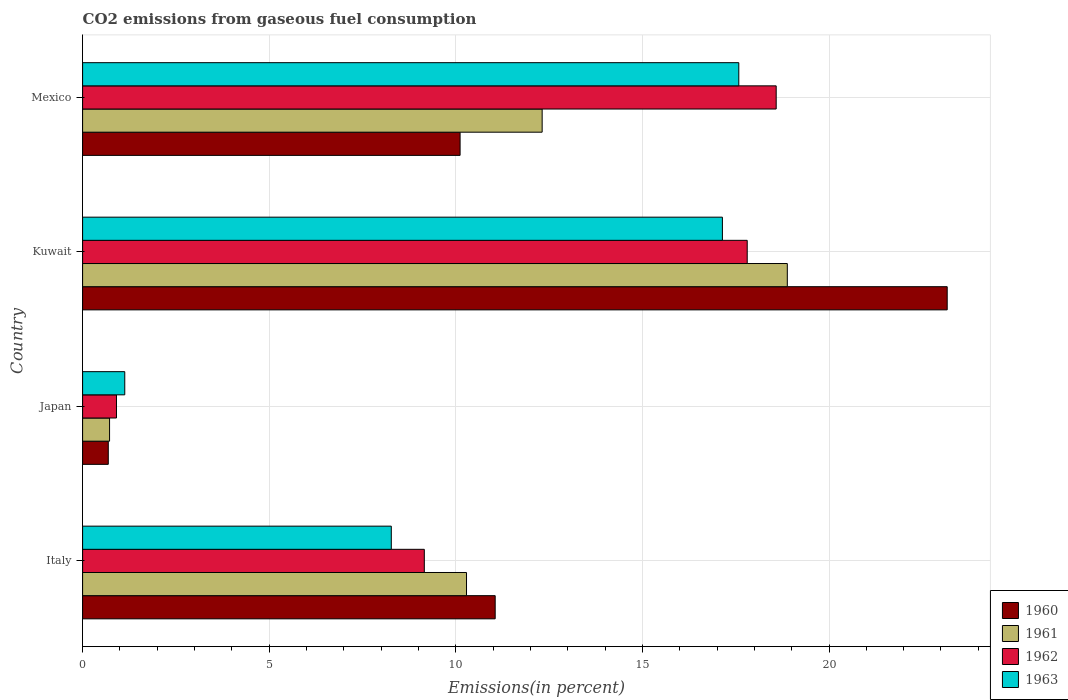How many different coloured bars are there?
Ensure brevity in your answer.  4. Are the number of bars per tick equal to the number of legend labels?
Offer a terse response. Yes. Are the number of bars on each tick of the Y-axis equal?
Make the answer very short. Yes. How many bars are there on the 3rd tick from the top?
Ensure brevity in your answer.  4. How many bars are there on the 4th tick from the bottom?
Make the answer very short. 4. What is the label of the 2nd group of bars from the top?
Your answer should be very brief. Kuwait. What is the total CO2 emitted in 1962 in Kuwait?
Offer a terse response. 17.81. Across all countries, what is the maximum total CO2 emitted in 1962?
Offer a very short reply. 18.59. Across all countries, what is the minimum total CO2 emitted in 1961?
Your answer should be compact. 0.72. What is the total total CO2 emitted in 1962 in the graph?
Give a very brief answer. 46.46. What is the difference between the total CO2 emitted in 1963 in Japan and that in Mexico?
Offer a very short reply. -16.45. What is the difference between the total CO2 emitted in 1962 in Japan and the total CO2 emitted in 1963 in Mexico?
Offer a very short reply. -16.68. What is the average total CO2 emitted in 1960 per country?
Offer a terse response. 11.26. What is the difference between the total CO2 emitted in 1961 and total CO2 emitted in 1962 in Italy?
Keep it short and to the point. 1.13. What is the ratio of the total CO2 emitted in 1963 in Japan to that in Kuwait?
Offer a terse response. 0.07. What is the difference between the highest and the second highest total CO2 emitted in 1961?
Provide a short and direct response. 6.57. What is the difference between the highest and the lowest total CO2 emitted in 1960?
Offer a very short reply. 22.48. Is the sum of the total CO2 emitted in 1962 in Italy and Kuwait greater than the maximum total CO2 emitted in 1960 across all countries?
Make the answer very short. Yes. What does the 1st bar from the top in Mexico represents?
Keep it short and to the point. 1963. What does the 2nd bar from the bottom in Japan represents?
Offer a very short reply. 1961. Are all the bars in the graph horizontal?
Offer a terse response. Yes. Where does the legend appear in the graph?
Provide a succinct answer. Bottom right. How many legend labels are there?
Give a very brief answer. 4. How are the legend labels stacked?
Offer a terse response. Vertical. What is the title of the graph?
Offer a terse response. CO2 emissions from gaseous fuel consumption. What is the label or title of the X-axis?
Give a very brief answer. Emissions(in percent). What is the label or title of the Y-axis?
Provide a short and direct response. Country. What is the Emissions(in percent) of 1960 in Italy?
Provide a short and direct response. 11.06. What is the Emissions(in percent) in 1961 in Italy?
Ensure brevity in your answer.  10.29. What is the Emissions(in percent) in 1962 in Italy?
Your answer should be compact. 9.16. What is the Emissions(in percent) in 1963 in Italy?
Your answer should be very brief. 8.27. What is the Emissions(in percent) in 1960 in Japan?
Provide a succinct answer. 0.69. What is the Emissions(in percent) of 1961 in Japan?
Your response must be concise. 0.72. What is the Emissions(in percent) in 1962 in Japan?
Give a very brief answer. 0.91. What is the Emissions(in percent) of 1963 in Japan?
Your answer should be very brief. 1.13. What is the Emissions(in percent) in 1960 in Kuwait?
Provide a succinct answer. 23.17. What is the Emissions(in percent) in 1961 in Kuwait?
Provide a short and direct response. 18.88. What is the Emissions(in percent) in 1962 in Kuwait?
Your answer should be very brief. 17.81. What is the Emissions(in percent) in 1963 in Kuwait?
Your response must be concise. 17.14. What is the Emissions(in percent) of 1960 in Mexico?
Offer a very short reply. 10.12. What is the Emissions(in percent) of 1961 in Mexico?
Your answer should be very brief. 12.31. What is the Emissions(in percent) in 1962 in Mexico?
Your answer should be compact. 18.59. What is the Emissions(in percent) of 1963 in Mexico?
Keep it short and to the point. 17.58. Across all countries, what is the maximum Emissions(in percent) of 1960?
Provide a short and direct response. 23.17. Across all countries, what is the maximum Emissions(in percent) of 1961?
Provide a short and direct response. 18.88. Across all countries, what is the maximum Emissions(in percent) of 1962?
Your answer should be compact. 18.59. Across all countries, what is the maximum Emissions(in percent) in 1963?
Your answer should be very brief. 17.58. Across all countries, what is the minimum Emissions(in percent) in 1960?
Your response must be concise. 0.69. Across all countries, what is the minimum Emissions(in percent) of 1961?
Give a very brief answer. 0.72. Across all countries, what is the minimum Emissions(in percent) in 1962?
Offer a terse response. 0.91. Across all countries, what is the minimum Emissions(in percent) in 1963?
Ensure brevity in your answer.  1.13. What is the total Emissions(in percent) in 1960 in the graph?
Give a very brief answer. 45.03. What is the total Emissions(in percent) in 1961 in the graph?
Your answer should be compact. 42.21. What is the total Emissions(in percent) of 1962 in the graph?
Provide a short and direct response. 46.46. What is the total Emissions(in percent) in 1963 in the graph?
Your answer should be compact. 44.13. What is the difference between the Emissions(in percent) in 1960 in Italy and that in Japan?
Provide a succinct answer. 10.37. What is the difference between the Emissions(in percent) of 1961 in Italy and that in Japan?
Your response must be concise. 9.56. What is the difference between the Emissions(in percent) of 1962 in Italy and that in Japan?
Keep it short and to the point. 8.25. What is the difference between the Emissions(in percent) in 1963 in Italy and that in Japan?
Provide a succinct answer. 7.14. What is the difference between the Emissions(in percent) in 1960 in Italy and that in Kuwait?
Make the answer very short. -12.11. What is the difference between the Emissions(in percent) in 1961 in Italy and that in Kuwait?
Your answer should be very brief. -8.6. What is the difference between the Emissions(in percent) of 1962 in Italy and that in Kuwait?
Your answer should be very brief. -8.65. What is the difference between the Emissions(in percent) in 1963 in Italy and that in Kuwait?
Make the answer very short. -8.87. What is the difference between the Emissions(in percent) of 1960 in Italy and that in Mexico?
Give a very brief answer. 0.94. What is the difference between the Emissions(in percent) in 1961 in Italy and that in Mexico?
Your response must be concise. -2.03. What is the difference between the Emissions(in percent) in 1962 in Italy and that in Mexico?
Provide a short and direct response. -9.43. What is the difference between the Emissions(in percent) of 1963 in Italy and that in Mexico?
Provide a succinct answer. -9.31. What is the difference between the Emissions(in percent) in 1960 in Japan and that in Kuwait?
Give a very brief answer. -22.48. What is the difference between the Emissions(in percent) in 1961 in Japan and that in Kuwait?
Make the answer very short. -18.16. What is the difference between the Emissions(in percent) of 1962 in Japan and that in Kuwait?
Provide a short and direct response. -16.9. What is the difference between the Emissions(in percent) in 1963 in Japan and that in Kuwait?
Offer a very short reply. -16.01. What is the difference between the Emissions(in percent) in 1960 in Japan and that in Mexico?
Ensure brevity in your answer.  -9.43. What is the difference between the Emissions(in percent) in 1961 in Japan and that in Mexico?
Your answer should be very brief. -11.59. What is the difference between the Emissions(in percent) of 1962 in Japan and that in Mexico?
Offer a terse response. -17.68. What is the difference between the Emissions(in percent) of 1963 in Japan and that in Mexico?
Offer a very short reply. -16.45. What is the difference between the Emissions(in percent) in 1960 in Kuwait and that in Mexico?
Ensure brevity in your answer.  13.05. What is the difference between the Emissions(in percent) in 1961 in Kuwait and that in Mexico?
Keep it short and to the point. 6.57. What is the difference between the Emissions(in percent) of 1962 in Kuwait and that in Mexico?
Your response must be concise. -0.78. What is the difference between the Emissions(in percent) in 1963 in Kuwait and that in Mexico?
Give a very brief answer. -0.44. What is the difference between the Emissions(in percent) in 1960 in Italy and the Emissions(in percent) in 1961 in Japan?
Provide a short and direct response. 10.33. What is the difference between the Emissions(in percent) of 1960 in Italy and the Emissions(in percent) of 1962 in Japan?
Your response must be concise. 10.15. What is the difference between the Emissions(in percent) in 1960 in Italy and the Emissions(in percent) in 1963 in Japan?
Provide a succinct answer. 9.93. What is the difference between the Emissions(in percent) of 1961 in Italy and the Emissions(in percent) of 1962 in Japan?
Give a very brief answer. 9.38. What is the difference between the Emissions(in percent) in 1961 in Italy and the Emissions(in percent) in 1963 in Japan?
Offer a very short reply. 9.16. What is the difference between the Emissions(in percent) in 1962 in Italy and the Emissions(in percent) in 1963 in Japan?
Ensure brevity in your answer.  8.03. What is the difference between the Emissions(in percent) in 1960 in Italy and the Emissions(in percent) in 1961 in Kuwait?
Offer a terse response. -7.83. What is the difference between the Emissions(in percent) in 1960 in Italy and the Emissions(in percent) in 1962 in Kuwait?
Make the answer very short. -6.75. What is the difference between the Emissions(in percent) of 1960 in Italy and the Emissions(in percent) of 1963 in Kuwait?
Your response must be concise. -6.09. What is the difference between the Emissions(in percent) in 1961 in Italy and the Emissions(in percent) in 1962 in Kuwait?
Your answer should be very brief. -7.52. What is the difference between the Emissions(in percent) of 1961 in Italy and the Emissions(in percent) of 1963 in Kuwait?
Provide a short and direct response. -6.86. What is the difference between the Emissions(in percent) in 1962 in Italy and the Emissions(in percent) in 1963 in Kuwait?
Your answer should be very brief. -7.99. What is the difference between the Emissions(in percent) in 1960 in Italy and the Emissions(in percent) in 1961 in Mexico?
Ensure brevity in your answer.  -1.26. What is the difference between the Emissions(in percent) of 1960 in Italy and the Emissions(in percent) of 1962 in Mexico?
Provide a succinct answer. -7.53. What is the difference between the Emissions(in percent) in 1960 in Italy and the Emissions(in percent) in 1963 in Mexico?
Offer a terse response. -6.53. What is the difference between the Emissions(in percent) in 1961 in Italy and the Emissions(in percent) in 1962 in Mexico?
Ensure brevity in your answer.  -8.3. What is the difference between the Emissions(in percent) in 1961 in Italy and the Emissions(in percent) in 1963 in Mexico?
Make the answer very short. -7.3. What is the difference between the Emissions(in percent) in 1962 in Italy and the Emissions(in percent) in 1963 in Mexico?
Provide a succinct answer. -8.43. What is the difference between the Emissions(in percent) of 1960 in Japan and the Emissions(in percent) of 1961 in Kuwait?
Keep it short and to the point. -18.19. What is the difference between the Emissions(in percent) in 1960 in Japan and the Emissions(in percent) in 1962 in Kuwait?
Your answer should be very brief. -17.12. What is the difference between the Emissions(in percent) of 1960 in Japan and the Emissions(in percent) of 1963 in Kuwait?
Make the answer very short. -16.46. What is the difference between the Emissions(in percent) of 1961 in Japan and the Emissions(in percent) of 1962 in Kuwait?
Give a very brief answer. -17.09. What is the difference between the Emissions(in percent) in 1961 in Japan and the Emissions(in percent) in 1963 in Kuwait?
Keep it short and to the point. -16.42. What is the difference between the Emissions(in percent) in 1962 in Japan and the Emissions(in percent) in 1963 in Kuwait?
Your response must be concise. -16.24. What is the difference between the Emissions(in percent) of 1960 in Japan and the Emissions(in percent) of 1961 in Mexico?
Your answer should be compact. -11.63. What is the difference between the Emissions(in percent) of 1960 in Japan and the Emissions(in percent) of 1962 in Mexico?
Ensure brevity in your answer.  -17.9. What is the difference between the Emissions(in percent) in 1960 in Japan and the Emissions(in percent) in 1963 in Mexico?
Your answer should be very brief. -16.89. What is the difference between the Emissions(in percent) in 1961 in Japan and the Emissions(in percent) in 1962 in Mexico?
Keep it short and to the point. -17.86. What is the difference between the Emissions(in percent) in 1961 in Japan and the Emissions(in percent) in 1963 in Mexico?
Provide a succinct answer. -16.86. What is the difference between the Emissions(in percent) in 1962 in Japan and the Emissions(in percent) in 1963 in Mexico?
Make the answer very short. -16.68. What is the difference between the Emissions(in percent) of 1960 in Kuwait and the Emissions(in percent) of 1961 in Mexico?
Offer a terse response. 10.85. What is the difference between the Emissions(in percent) of 1960 in Kuwait and the Emissions(in percent) of 1962 in Mexico?
Your answer should be compact. 4.58. What is the difference between the Emissions(in percent) in 1960 in Kuwait and the Emissions(in percent) in 1963 in Mexico?
Provide a short and direct response. 5.58. What is the difference between the Emissions(in percent) in 1961 in Kuwait and the Emissions(in percent) in 1962 in Mexico?
Ensure brevity in your answer.  0.3. What is the difference between the Emissions(in percent) of 1961 in Kuwait and the Emissions(in percent) of 1963 in Mexico?
Give a very brief answer. 1.3. What is the difference between the Emissions(in percent) of 1962 in Kuwait and the Emissions(in percent) of 1963 in Mexico?
Provide a succinct answer. 0.23. What is the average Emissions(in percent) of 1960 per country?
Provide a short and direct response. 11.26. What is the average Emissions(in percent) in 1961 per country?
Offer a terse response. 10.55. What is the average Emissions(in percent) of 1962 per country?
Keep it short and to the point. 11.61. What is the average Emissions(in percent) of 1963 per country?
Your response must be concise. 11.03. What is the difference between the Emissions(in percent) in 1960 and Emissions(in percent) in 1961 in Italy?
Offer a terse response. 0.77. What is the difference between the Emissions(in percent) of 1960 and Emissions(in percent) of 1962 in Italy?
Make the answer very short. 1.9. What is the difference between the Emissions(in percent) in 1960 and Emissions(in percent) in 1963 in Italy?
Your answer should be very brief. 2.78. What is the difference between the Emissions(in percent) in 1961 and Emissions(in percent) in 1962 in Italy?
Keep it short and to the point. 1.13. What is the difference between the Emissions(in percent) in 1961 and Emissions(in percent) in 1963 in Italy?
Make the answer very short. 2.02. What is the difference between the Emissions(in percent) of 1962 and Emissions(in percent) of 1963 in Italy?
Offer a terse response. 0.88. What is the difference between the Emissions(in percent) of 1960 and Emissions(in percent) of 1961 in Japan?
Offer a terse response. -0.03. What is the difference between the Emissions(in percent) in 1960 and Emissions(in percent) in 1962 in Japan?
Provide a succinct answer. -0.22. What is the difference between the Emissions(in percent) in 1960 and Emissions(in percent) in 1963 in Japan?
Provide a short and direct response. -0.44. What is the difference between the Emissions(in percent) in 1961 and Emissions(in percent) in 1962 in Japan?
Provide a short and direct response. -0.19. What is the difference between the Emissions(in percent) in 1961 and Emissions(in percent) in 1963 in Japan?
Offer a terse response. -0.41. What is the difference between the Emissions(in percent) of 1962 and Emissions(in percent) of 1963 in Japan?
Your response must be concise. -0.22. What is the difference between the Emissions(in percent) in 1960 and Emissions(in percent) in 1961 in Kuwait?
Provide a succinct answer. 4.28. What is the difference between the Emissions(in percent) of 1960 and Emissions(in percent) of 1962 in Kuwait?
Your answer should be very brief. 5.36. What is the difference between the Emissions(in percent) in 1960 and Emissions(in percent) in 1963 in Kuwait?
Keep it short and to the point. 6.02. What is the difference between the Emissions(in percent) of 1961 and Emissions(in percent) of 1962 in Kuwait?
Offer a terse response. 1.07. What is the difference between the Emissions(in percent) in 1961 and Emissions(in percent) in 1963 in Kuwait?
Your response must be concise. 1.74. What is the difference between the Emissions(in percent) of 1962 and Emissions(in percent) of 1963 in Kuwait?
Keep it short and to the point. 0.66. What is the difference between the Emissions(in percent) of 1960 and Emissions(in percent) of 1961 in Mexico?
Provide a short and direct response. -2.2. What is the difference between the Emissions(in percent) in 1960 and Emissions(in percent) in 1962 in Mexico?
Make the answer very short. -8.47. What is the difference between the Emissions(in percent) in 1960 and Emissions(in percent) in 1963 in Mexico?
Offer a terse response. -7.47. What is the difference between the Emissions(in percent) in 1961 and Emissions(in percent) in 1962 in Mexico?
Offer a very short reply. -6.27. What is the difference between the Emissions(in percent) in 1961 and Emissions(in percent) in 1963 in Mexico?
Your response must be concise. -5.27. What is the ratio of the Emissions(in percent) of 1960 in Italy to that in Japan?
Your response must be concise. 16.06. What is the ratio of the Emissions(in percent) in 1961 in Italy to that in Japan?
Make the answer very short. 14.23. What is the ratio of the Emissions(in percent) of 1962 in Italy to that in Japan?
Provide a short and direct response. 10.09. What is the ratio of the Emissions(in percent) in 1963 in Italy to that in Japan?
Offer a terse response. 7.32. What is the ratio of the Emissions(in percent) in 1960 in Italy to that in Kuwait?
Offer a very short reply. 0.48. What is the ratio of the Emissions(in percent) of 1961 in Italy to that in Kuwait?
Your answer should be compact. 0.54. What is the ratio of the Emissions(in percent) in 1962 in Italy to that in Kuwait?
Provide a succinct answer. 0.51. What is the ratio of the Emissions(in percent) in 1963 in Italy to that in Kuwait?
Make the answer very short. 0.48. What is the ratio of the Emissions(in percent) in 1960 in Italy to that in Mexico?
Make the answer very short. 1.09. What is the ratio of the Emissions(in percent) in 1961 in Italy to that in Mexico?
Your answer should be compact. 0.84. What is the ratio of the Emissions(in percent) of 1962 in Italy to that in Mexico?
Ensure brevity in your answer.  0.49. What is the ratio of the Emissions(in percent) in 1963 in Italy to that in Mexico?
Offer a terse response. 0.47. What is the ratio of the Emissions(in percent) of 1960 in Japan to that in Kuwait?
Your answer should be very brief. 0.03. What is the ratio of the Emissions(in percent) of 1961 in Japan to that in Kuwait?
Ensure brevity in your answer.  0.04. What is the ratio of the Emissions(in percent) in 1962 in Japan to that in Kuwait?
Your answer should be very brief. 0.05. What is the ratio of the Emissions(in percent) of 1963 in Japan to that in Kuwait?
Provide a short and direct response. 0.07. What is the ratio of the Emissions(in percent) of 1960 in Japan to that in Mexico?
Offer a very short reply. 0.07. What is the ratio of the Emissions(in percent) in 1961 in Japan to that in Mexico?
Offer a terse response. 0.06. What is the ratio of the Emissions(in percent) in 1962 in Japan to that in Mexico?
Make the answer very short. 0.05. What is the ratio of the Emissions(in percent) of 1963 in Japan to that in Mexico?
Give a very brief answer. 0.06. What is the ratio of the Emissions(in percent) in 1960 in Kuwait to that in Mexico?
Provide a succinct answer. 2.29. What is the ratio of the Emissions(in percent) in 1961 in Kuwait to that in Mexico?
Keep it short and to the point. 1.53. What is the ratio of the Emissions(in percent) of 1962 in Kuwait to that in Mexico?
Provide a short and direct response. 0.96. What is the difference between the highest and the second highest Emissions(in percent) in 1960?
Give a very brief answer. 12.11. What is the difference between the highest and the second highest Emissions(in percent) of 1961?
Provide a short and direct response. 6.57. What is the difference between the highest and the second highest Emissions(in percent) in 1962?
Keep it short and to the point. 0.78. What is the difference between the highest and the second highest Emissions(in percent) of 1963?
Your answer should be very brief. 0.44. What is the difference between the highest and the lowest Emissions(in percent) of 1960?
Your answer should be very brief. 22.48. What is the difference between the highest and the lowest Emissions(in percent) in 1961?
Offer a terse response. 18.16. What is the difference between the highest and the lowest Emissions(in percent) in 1962?
Your response must be concise. 17.68. What is the difference between the highest and the lowest Emissions(in percent) in 1963?
Keep it short and to the point. 16.45. 